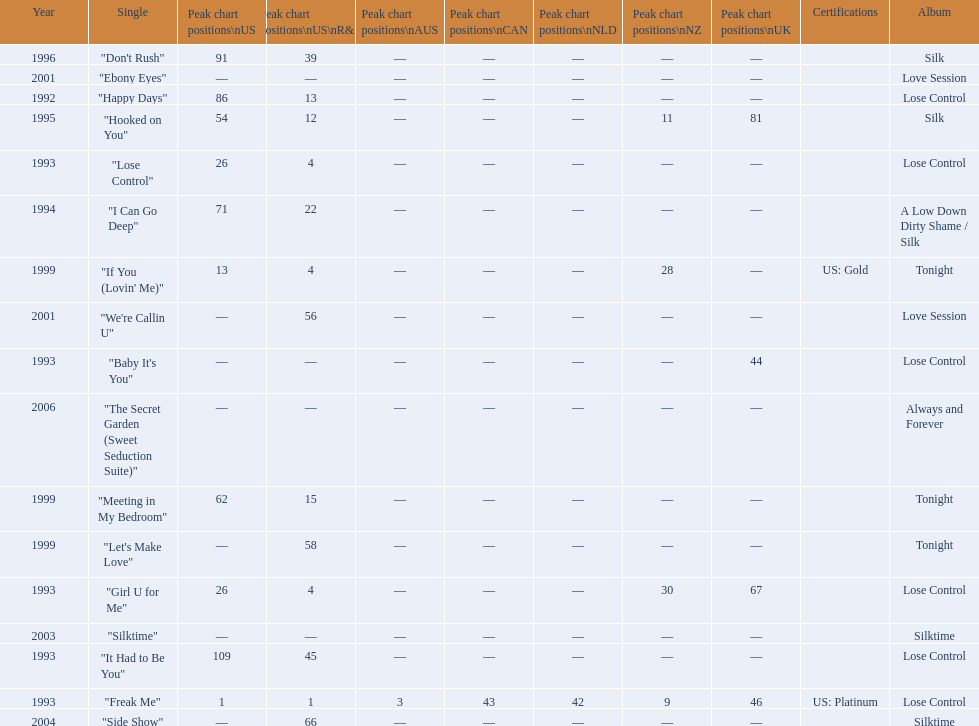Compare "i can go deep" with "don't rush". which was higher on the us and us r&b charts? "I Can Go Deep". 